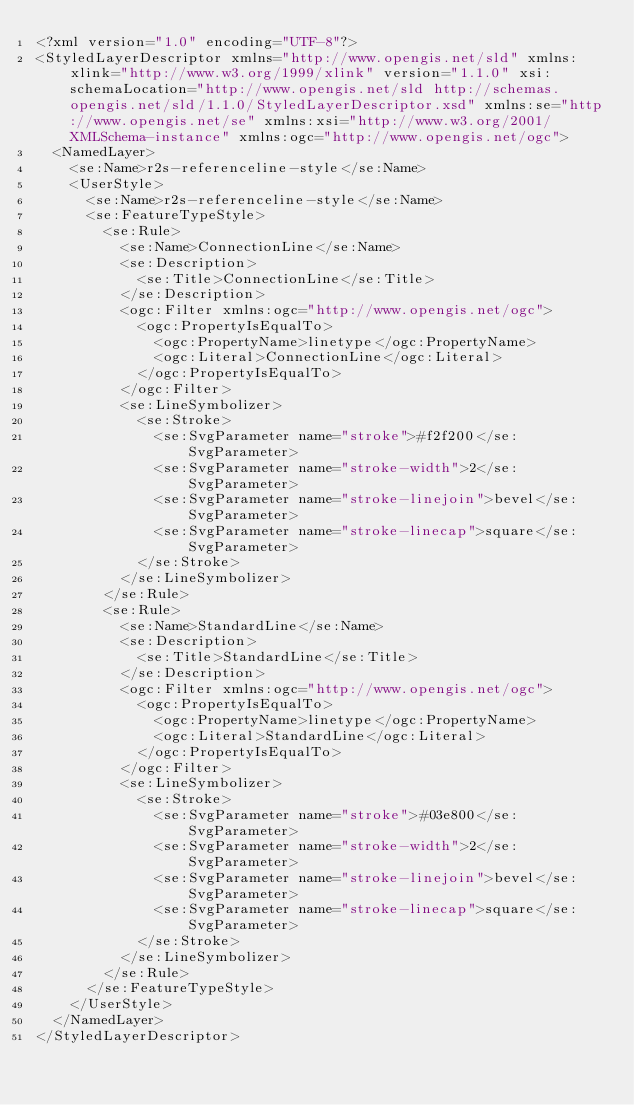Convert code to text. <code><loc_0><loc_0><loc_500><loc_500><_Scheme_><?xml version="1.0" encoding="UTF-8"?>
<StyledLayerDescriptor xmlns="http://www.opengis.net/sld" xmlns:xlink="http://www.w3.org/1999/xlink" version="1.1.0" xsi:schemaLocation="http://www.opengis.net/sld http://schemas.opengis.net/sld/1.1.0/StyledLayerDescriptor.xsd" xmlns:se="http://www.opengis.net/se" xmlns:xsi="http://www.w3.org/2001/XMLSchema-instance" xmlns:ogc="http://www.opengis.net/ogc">
  <NamedLayer>
    <se:Name>r2s-referenceline-style</se:Name>
    <UserStyle>
      <se:Name>r2s-referenceline-style</se:Name>
      <se:FeatureTypeStyle>
        <se:Rule>
          <se:Name>ConnectionLine</se:Name>
          <se:Description>
            <se:Title>ConnectionLine</se:Title>
          </se:Description>
          <ogc:Filter xmlns:ogc="http://www.opengis.net/ogc">
            <ogc:PropertyIsEqualTo>
              <ogc:PropertyName>linetype</ogc:PropertyName>
              <ogc:Literal>ConnectionLine</ogc:Literal>
            </ogc:PropertyIsEqualTo>
          </ogc:Filter>
          <se:LineSymbolizer>
            <se:Stroke>
              <se:SvgParameter name="stroke">#f2f200</se:SvgParameter>
              <se:SvgParameter name="stroke-width">2</se:SvgParameter>
              <se:SvgParameter name="stroke-linejoin">bevel</se:SvgParameter>
              <se:SvgParameter name="stroke-linecap">square</se:SvgParameter>
            </se:Stroke>
          </se:LineSymbolizer>
        </se:Rule>
        <se:Rule>
          <se:Name>StandardLine</se:Name>
          <se:Description>
            <se:Title>StandardLine</se:Title>
          </se:Description>
          <ogc:Filter xmlns:ogc="http://www.opengis.net/ogc">
            <ogc:PropertyIsEqualTo>
              <ogc:PropertyName>linetype</ogc:PropertyName>
              <ogc:Literal>StandardLine</ogc:Literal>
            </ogc:PropertyIsEqualTo>
          </ogc:Filter>
          <se:LineSymbolizer>
            <se:Stroke>
              <se:SvgParameter name="stroke">#03e800</se:SvgParameter>
              <se:SvgParameter name="stroke-width">2</se:SvgParameter>
              <se:SvgParameter name="stroke-linejoin">bevel</se:SvgParameter>
              <se:SvgParameter name="stroke-linecap">square</se:SvgParameter>
            </se:Stroke>
          </se:LineSymbolizer>
        </se:Rule>
      </se:FeatureTypeStyle>
    </UserStyle>
  </NamedLayer>
</StyledLayerDescriptor>
</code> 